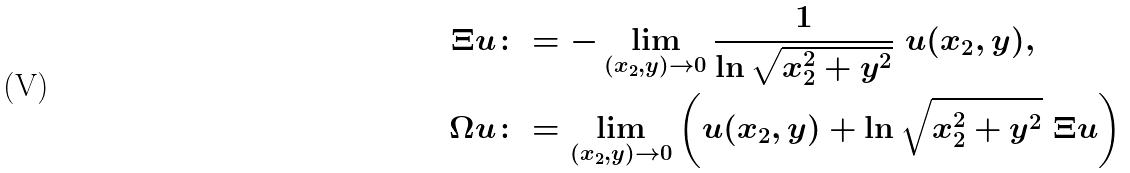<formula> <loc_0><loc_0><loc_500><loc_500>\Xi u & \colon = - \lim _ { ( x _ { 2 } , y ) \rightarrow 0 } \frac { 1 } { \ln \sqrt { x _ { 2 } ^ { 2 } + y ^ { 2 } } } \ u ( x _ { 2 } , y ) , \\ \Omega u & \colon = \lim _ { ( x _ { 2 } , y ) \rightarrow 0 } \left ( u ( x _ { 2 } , y ) + \ln \sqrt { x _ { 2 } ^ { 2 } + y ^ { 2 } } \ \Xi u \right )</formula> 